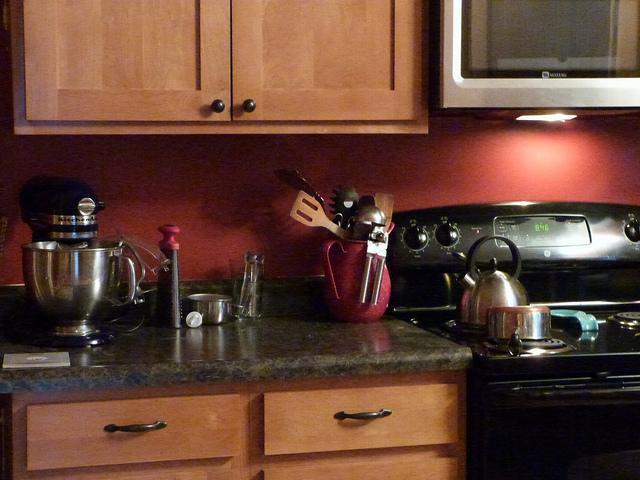What fuels the stove?
Make your selection from the four choices given to correctly answer the question.
Options: Gas, charcoal, microwave, electricity. Electricity. 